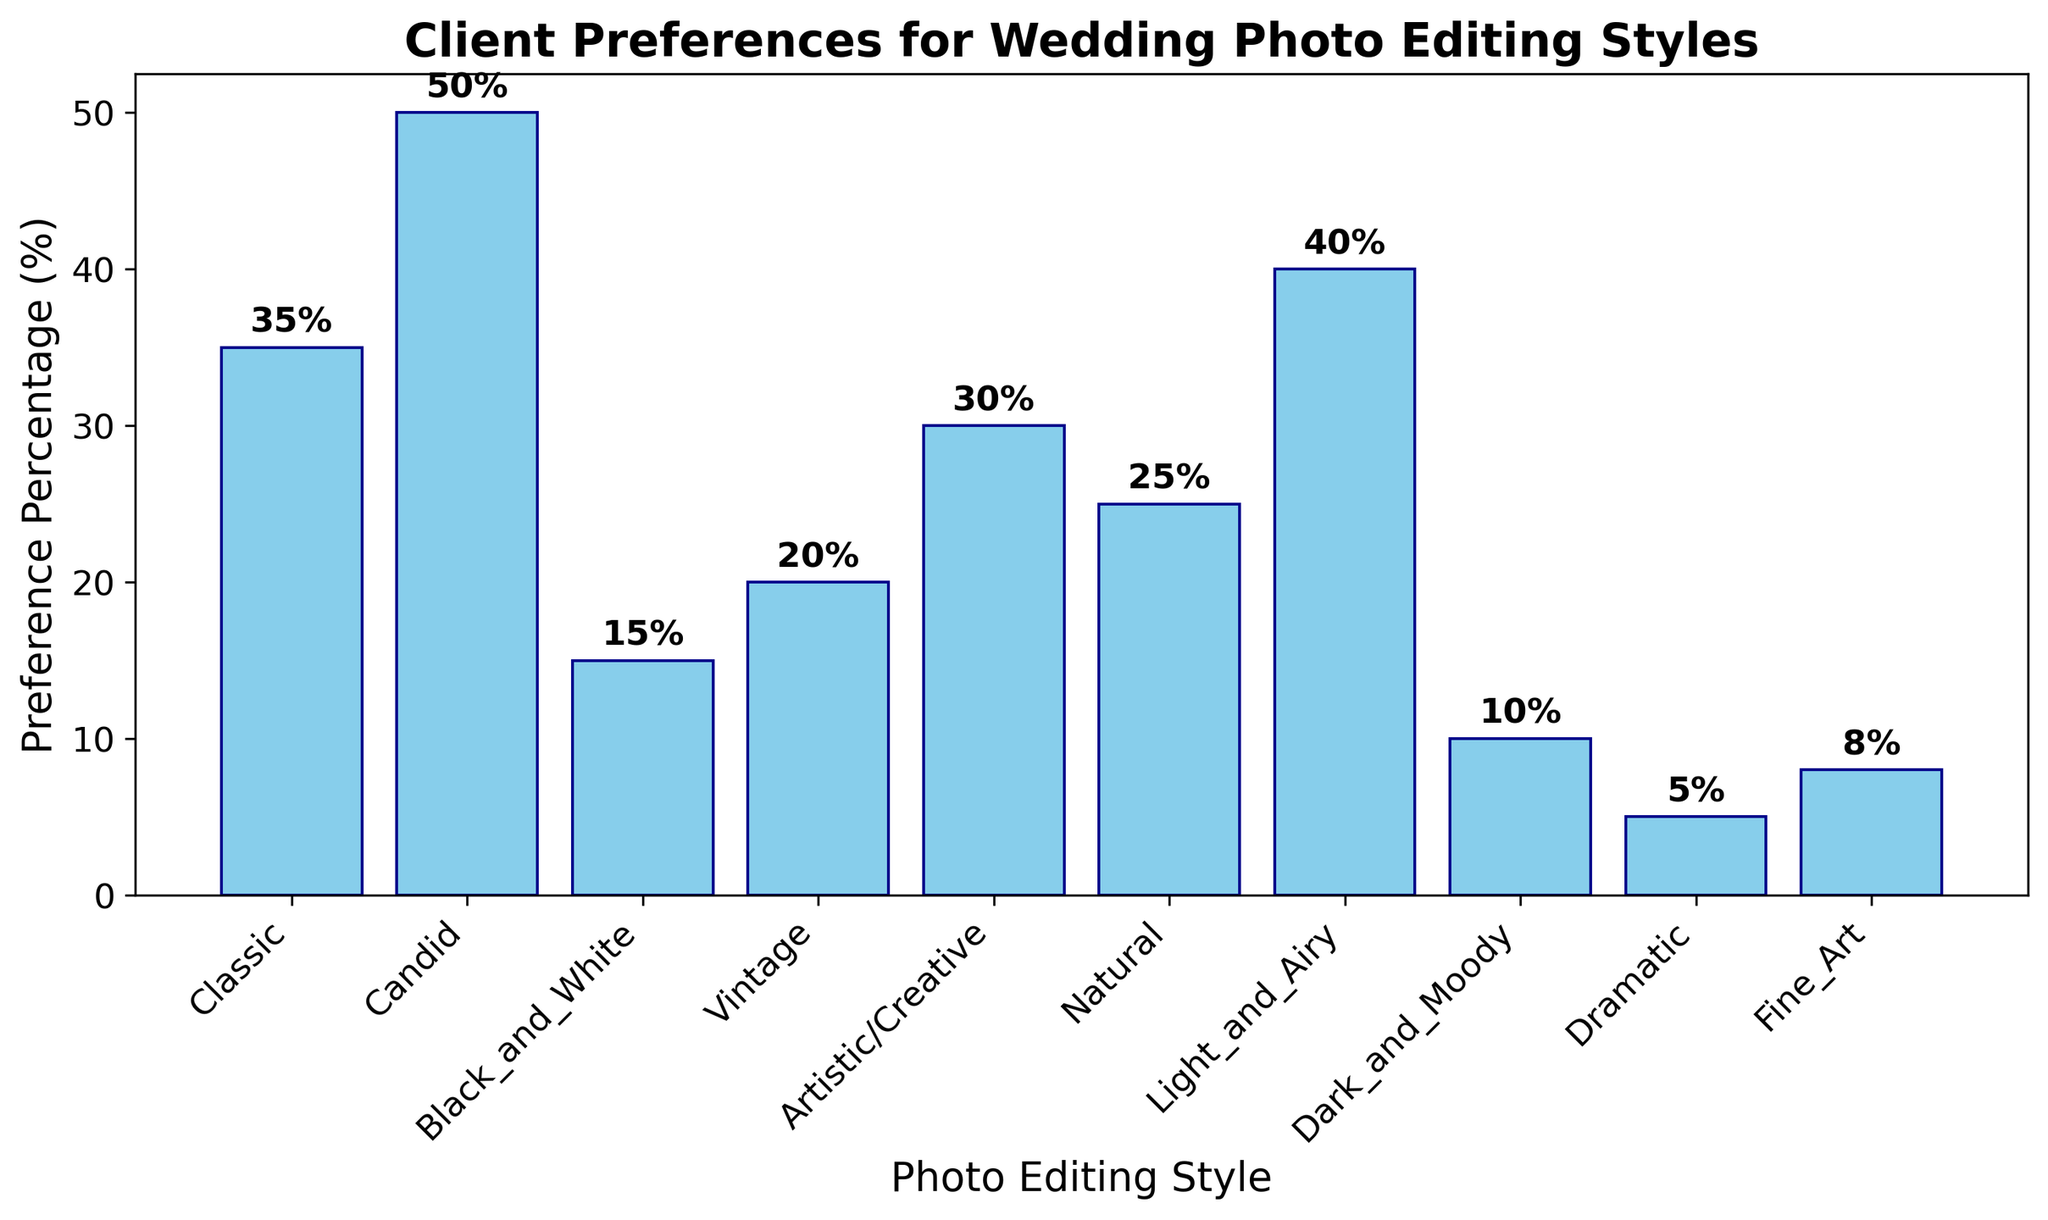What photo editing style has the highest preference percentage? Look at the height of the bars on the chart. The tallest bar represents the style with the highest preference. In this case, it is 'Candid' with 50%.
Answer: Candid What is the difference in preference percentage between 'Classic' and 'Dark and Moody'? Calculate the difference by subtracting the smaller percentage from the larger one. For 'Classic' it is 35%, and for 'Dark and Moody' it is 10%. Thus, 35% - 10% = 25%.
Answer: 25% Which photo editing styles have a preference percentage above 30%? Identify the bars that are taller than the 30% mark. The styles that meet this criterion are 'Classic' (35%), 'Candid' (50%), and 'Light_and_Airy' (40%).
Answer: Classic, Candid, Light_and_Airy How many photo editing styles have a preference percentage below 20%? Count the number of bars with a height below the 20% mark. These are 'Black and White' (15%), 'Dark and Moody' (10%), 'Dramatic' (5%), and 'Fine Art' (8%). Thus, there are four styles.
Answer: 4 What is the combined preference percentage of 'Vintage' and 'Artistic/Creative'? Add the percentages given for 'Vintage' and 'Artistic/Creative'. 'Vintage' has 20% and 'Artistic/Creative' has 30%, resulting in 20% + 30% = 50%.
Answer: 50% Which style has the lowest preference percentage and what is that percentage? Look for the shortest bar on the chart, which represents the style with the lowest preference. 'Dramatic' has the lowest percentage at 5%.
Answer: Dramatic, 5% Are there more styles with a preference percentage above 25% or below 25%? Count the bars above and below the 25% mark. Above 25% are 'Classic' (35%), 'Candid' (50%), 'Light_and_Airy' (40%), and 'Artistic/Creative' (30%)—4 styles. Below 25% are 'Black and White' (15%), 'Vintage' (20%), 'Natural' (25%), 'Dark and Moody' (10%), 'Dramatic' (5%), and 'Fine Art' (8%)—6 styles. There are more styles below 25%.
Answer: Below 25% What is the average preference percentage for the photo editing styles that have percentages between 10% and 30%? Identify the styles in the 10%-30% range: 'Black and White' (15%), 'Vintage' (20%), 'Artistic/Creative' (30%), and 'Natural' (25%). Calculate the average by summing these percentages and dividing by the number of styles: (15% + 20% + 30% + 25%) / 4 = 90% / 4 = 22.5%.
Answer: 22.5% Which styles have both less than 40% and a greater preference percentage than 'Natural'? Identify styles with less than 40% and greater than 25%. These are 'Classic' (35%), 'Artistic/Creative' (30%), and 'Vintage' (20%). However, 'Vintage' does not meet the criterion, so remaining are 'Classic' and 'Artistic/Creative'.
Answer: Classic, Artistic/Creative 